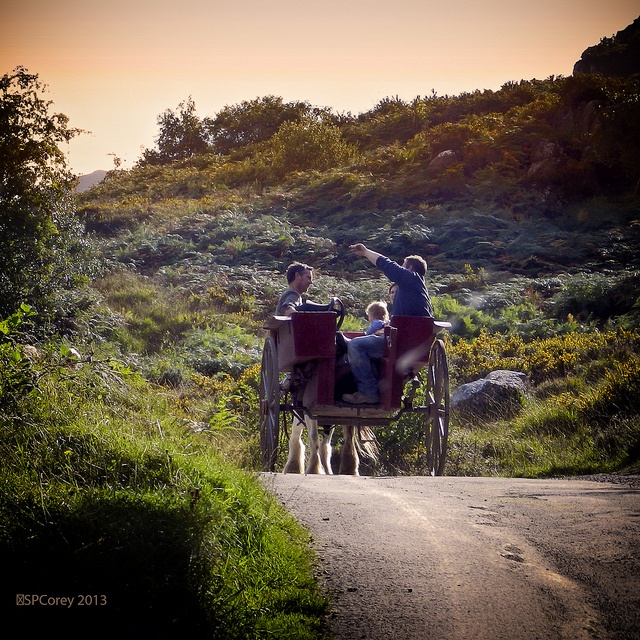Describe the objects in this image and their specific colors. I can see people in gray, navy, and darkgray tones, horse in brown, black, gray, ivory, and darkgray tones, people in gray, black, navy, and purple tones, and people in gray, blue, white, and purple tones in this image. 